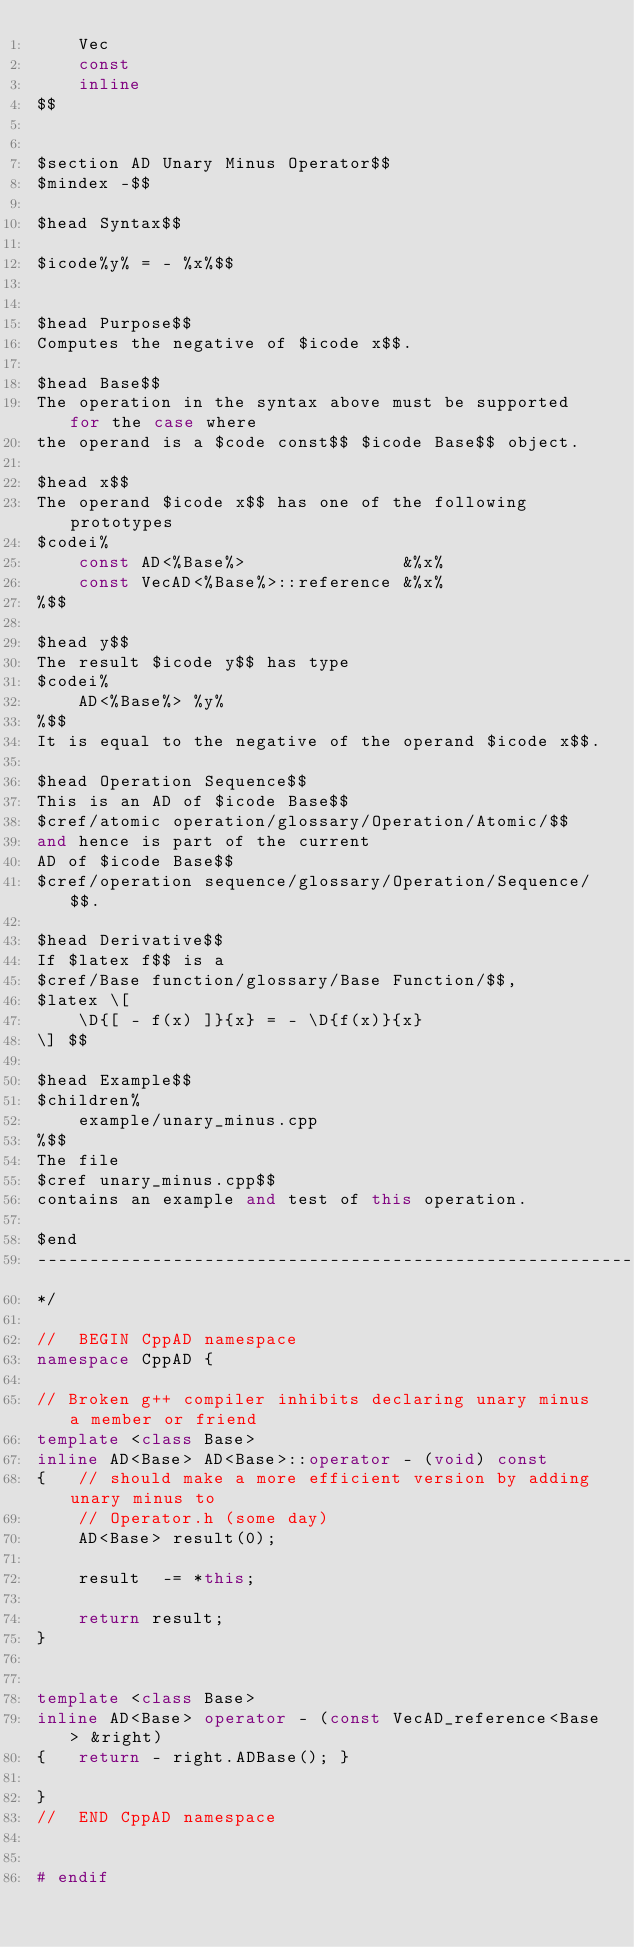Convert code to text. <code><loc_0><loc_0><loc_500><loc_500><_C++_>	Vec
	const
	inline
$$


$section AD Unary Minus Operator$$
$mindex -$$

$head Syntax$$

$icode%y% = - %x%$$


$head Purpose$$
Computes the negative of $icode x$$.

$head Base$$
The operation in the syntax above must be supported for the case where
the operand is a $code const$$ $icode Base$$ object.

$head x$$
The operand $icode x$$ has one of the following prototypes
$codei%
	const AD<%Base%>               &%x%
	const VecAD<%Base%>::reference &%x%
%$$

$head y$$
The result $icode y$$ has type
$codei%
	AD<%Base%> %y%
%$$
It is equal to the negative of the operand $icode x$$.

$head Operation Sequence$$
This is an AD of $icode Base$$
$cref/atomic operation/glossary/Operation/Atomic/$$
and hence is part of the current
AD of $icode Base$$
$cref/operation sequence/glossary/Operation/Sequence/$$.

$head Derivative$$
If $latex f$$ is a
$cref/Base function/glossary/Base Function/$$,
$latex \[
	\D{[ - f(x) ]}{x} = - \D{f(x)}{x}
\] $$

$head Example$$
$children%
	example/unary_minus.cpp
%$$
The file
$cref unary_minus.cpp$$
contains an example and test of this operation.

$end
-------------------------------------------------------------------------------
*/

//  BEGIN CppAD namespace
namespace CppAD {

// Broken g++ compiler inhibits declaring unary minus a member or friend
template <class Base>
inline AD<Base> AD<Base>::operator - (void) const
{	// should make a more efficient version by adding unary minus to
	// Operator.h (some day)
	AD<Base> result(0);

	result  -= *this;

	return result;
}


template <class Base>
inline AD<Base> operator - (const VecAD_reference<Base> &right)
{	return - right.ADBase(); }

}
//  END CppAD namespace


# endif
</code> 